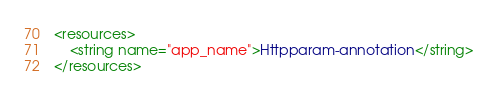<code> <loc_0><loc_0><loc_500><loc_500><_XML_><resources>
    <string name="app_name">Httpparam-annotation</string>
</resources>
</code> 